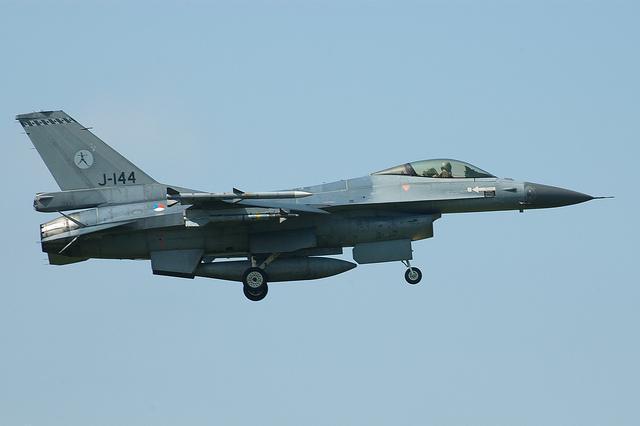How many wheels are on the jet?
Give a very brief answer. 3. How many airplanes can be seen?
Give a very brief answer. 1. 